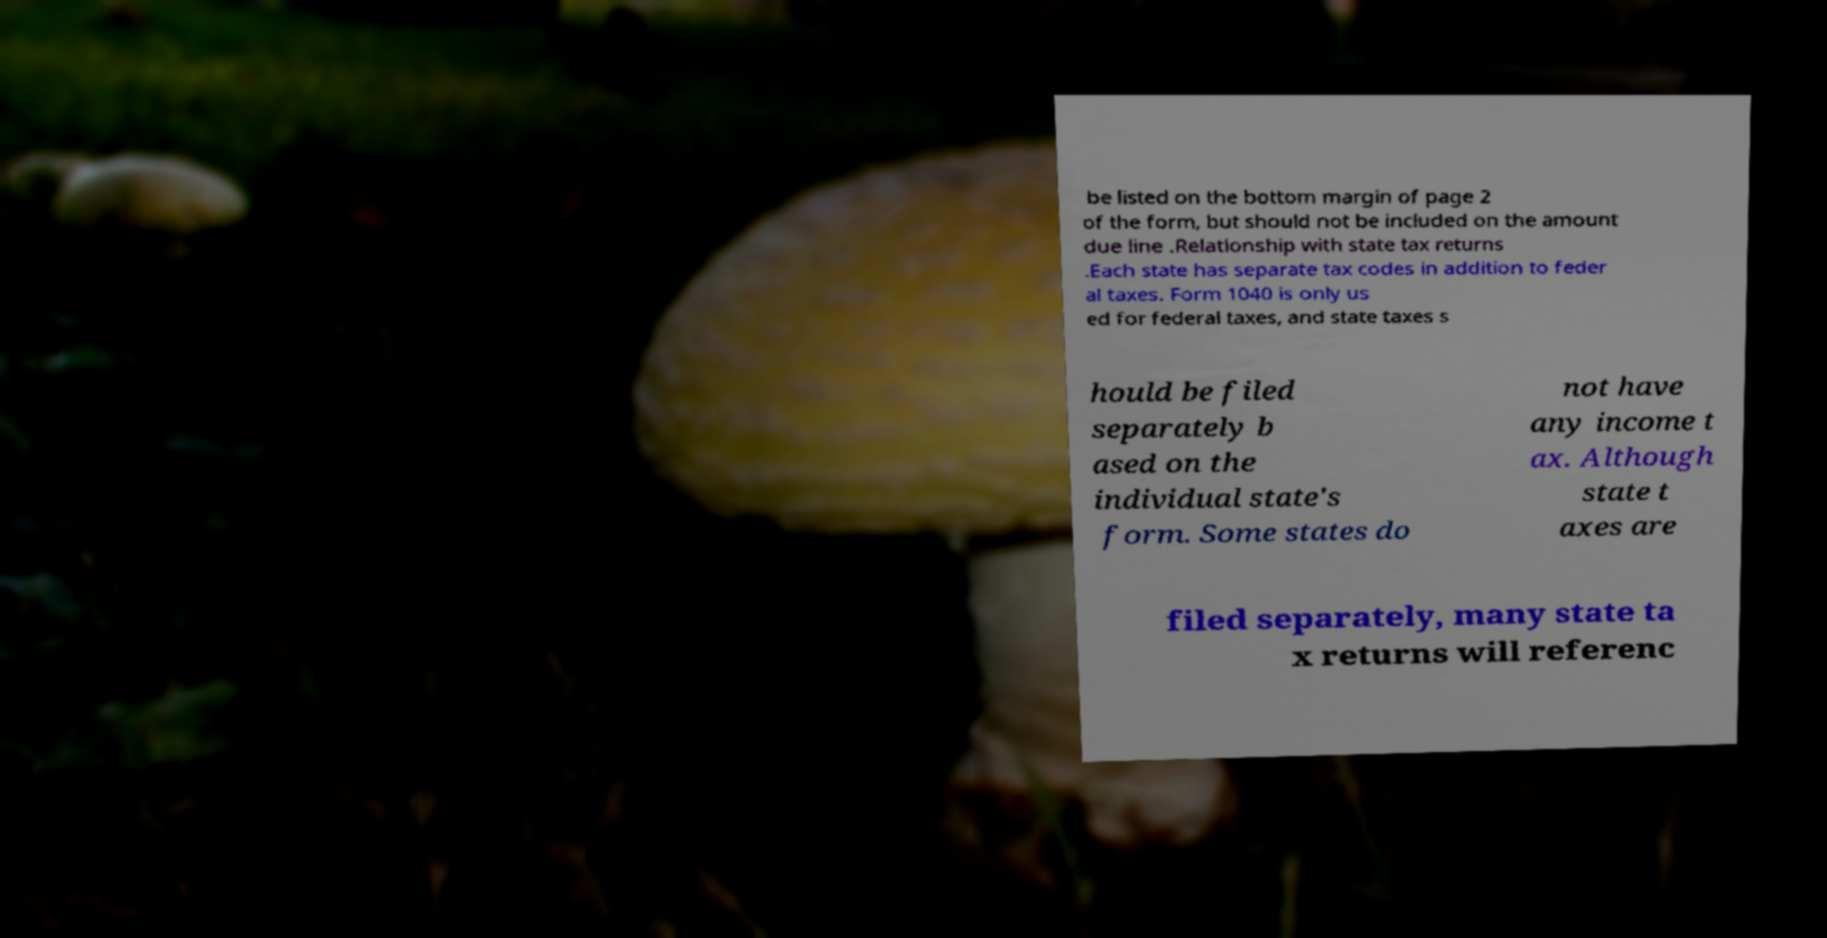For documentation purposes, I need the text within this image transcribed. Could you provide that? be listed on the bottom margin of page 2 of the form, but should not be included on the amount due line .Relationship with state tax returns .Each state has separate tax codes in addition to feder al taxes. Form 1040 is only us ed for federal taxes, and state taxes s hould be filed separately b ased on the individual state's form. Some states do not have any income t ax. Although state t axes are filed separately, many state ta x returns will referenc 